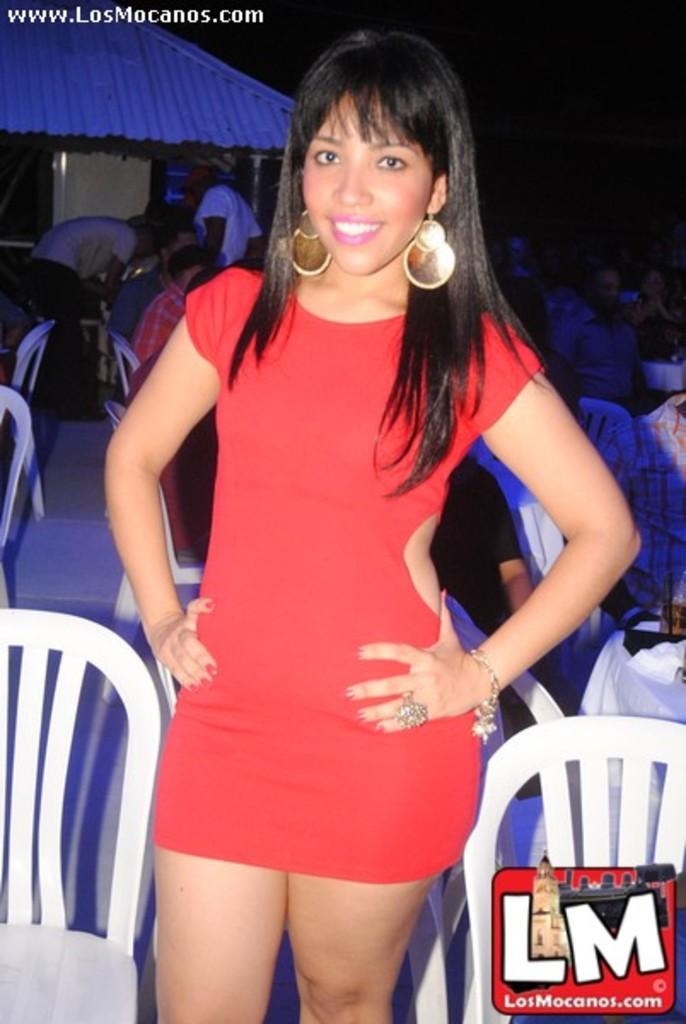<image>
Provide a brief description of the given image. A girl wearing a red dress stands in front of a bar called Los Mocanos 